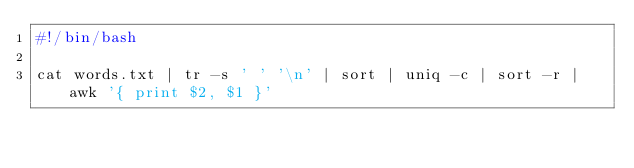<code> <loc_0><loc_0><loc_500><loc_500><_Bash_>#!/bin/bash

cat words.txt | tr -s ' ' '\n' | sort | uniq -c | sort -r | awk '{ print $2, $1 }'

</code> 